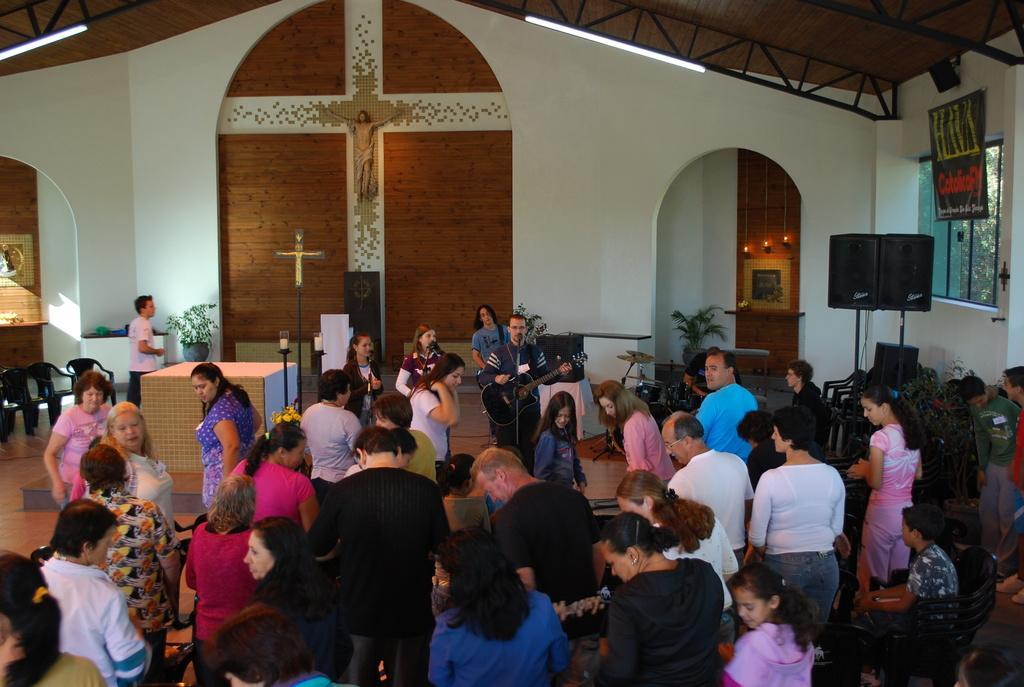Could you give a brief overview of what you see in this image? In this image I can see group of people standing and I can also see the person playing the musical instrument and I can see few microphones. In the background I can see the cross symbol, few plants in green color, glass windows, lights and I can also see the statue. 